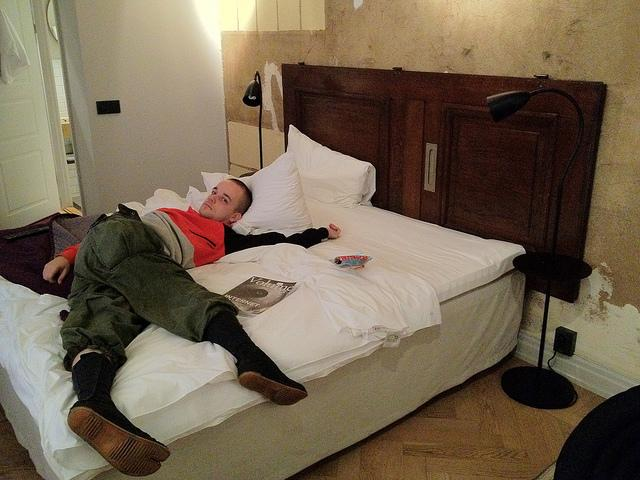What is next to the bed?

Choices:
A) dog
B) baby
C) cat
D) lamp lamp 